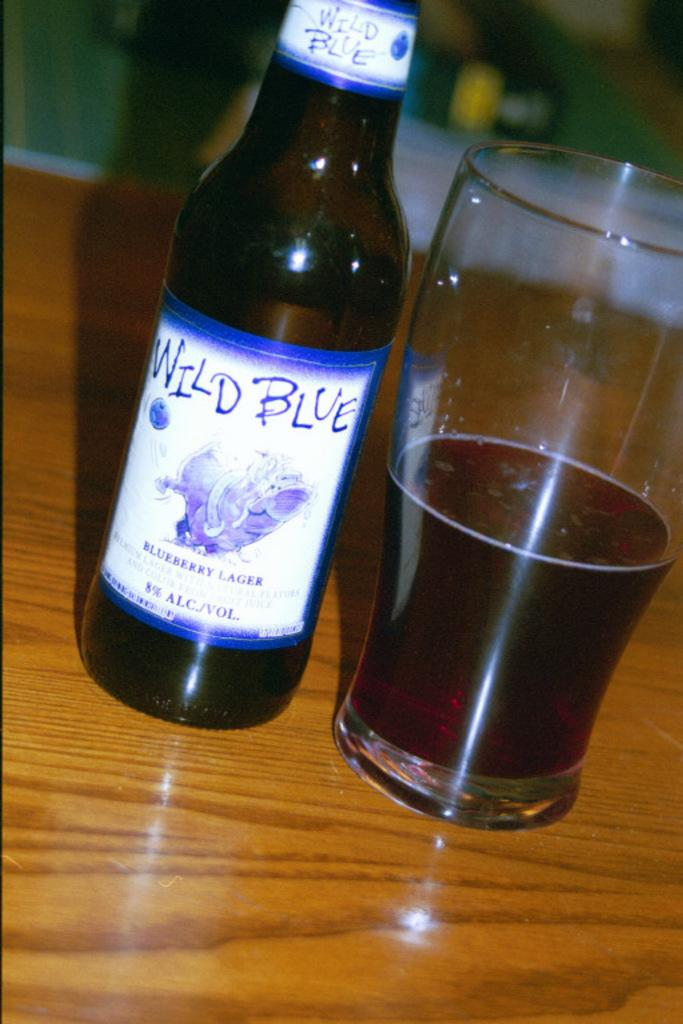What type of surface is visible in the image? There is a wooden surface in the image. What objects are placed on the wooden surface? There is a bottle and a glass on the wooden surface. What is inside the glass? The glass contains a liquid. How would you describe the background of the image? The background of the image is blurred. What type of knee can be seen in the image? There is no knee present in the image. What is the night doing in the image? The night is not an object or element in the image; it is a time of day. 